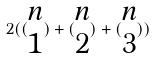<formula> <loc_0><loc_0><loc_500><loc_500>2 ( ( \begin{matrix} n \\ 1 \end{matrix} ) + ( \begin{matrix} n \\ 2 \end{matrix} ) + ( \begin{matrix} n \\ 3 \end{matrix} ) )</formula> 